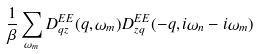Convert formula to latex. <formula><loc_0><loc_0><loc_500><loc_500>\frac { 1 } { \beta } \sum _ { \omega _ { m } } D _ { q z } ^ { E E } ( q , \omega _ { m } ) D _ { z q } ^ { E E } ( - q , i \omega _ { n } - i \omega _ { m } )</formula> 